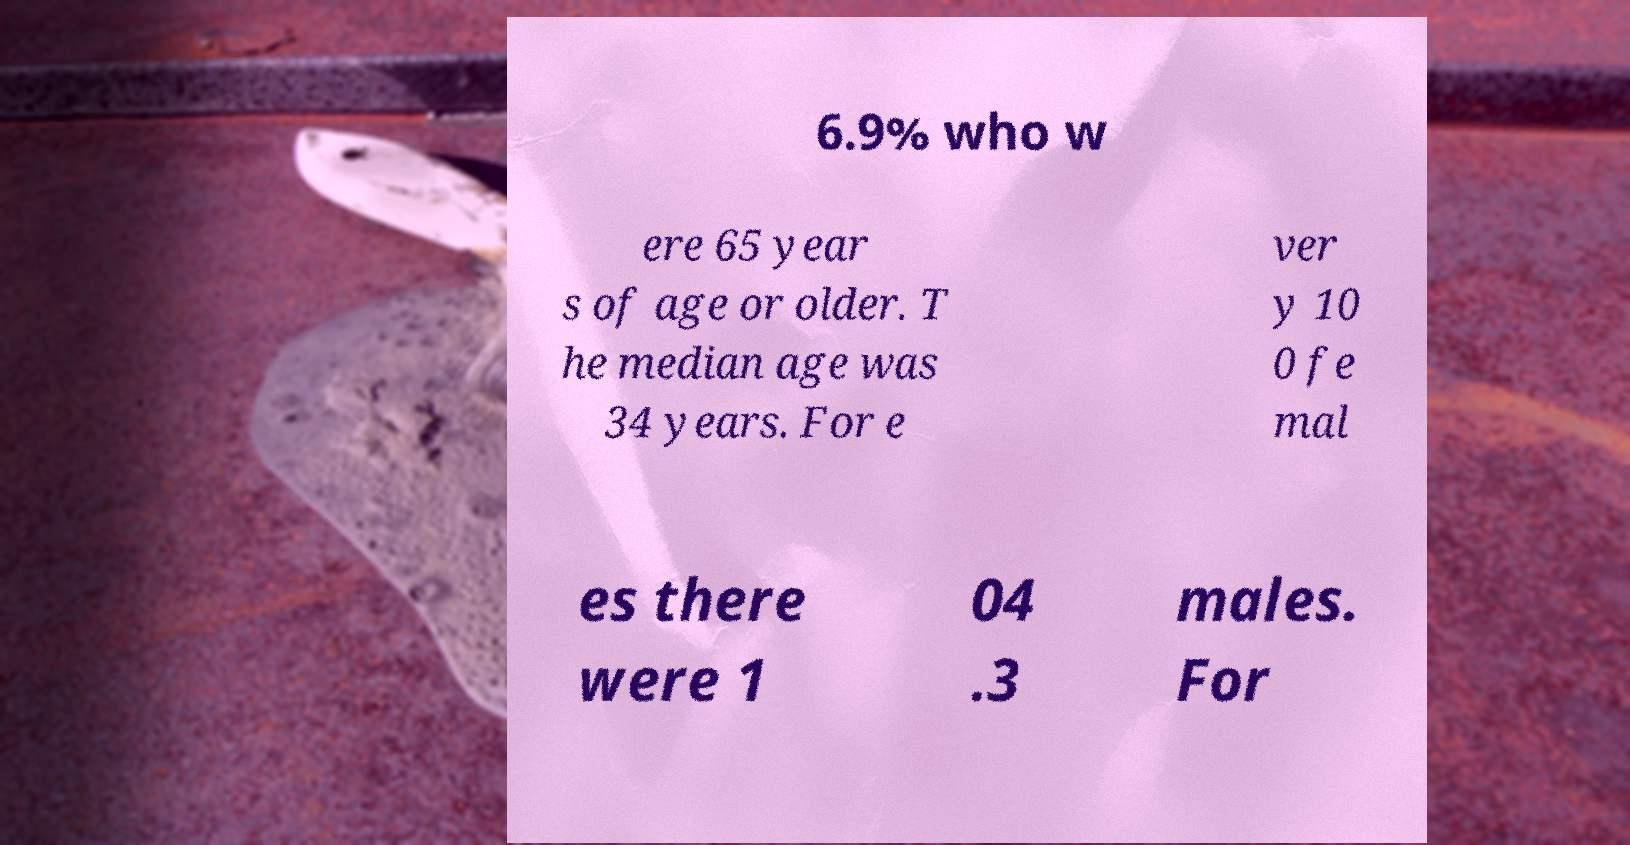Could you assist in decoding the text presented in this image and type it out clearly? 6.9% who w ere 65 year s of age or older. T he median age was 34 years. For e ver y 10 0 fe mal es there were 1 04 .3 males. For 